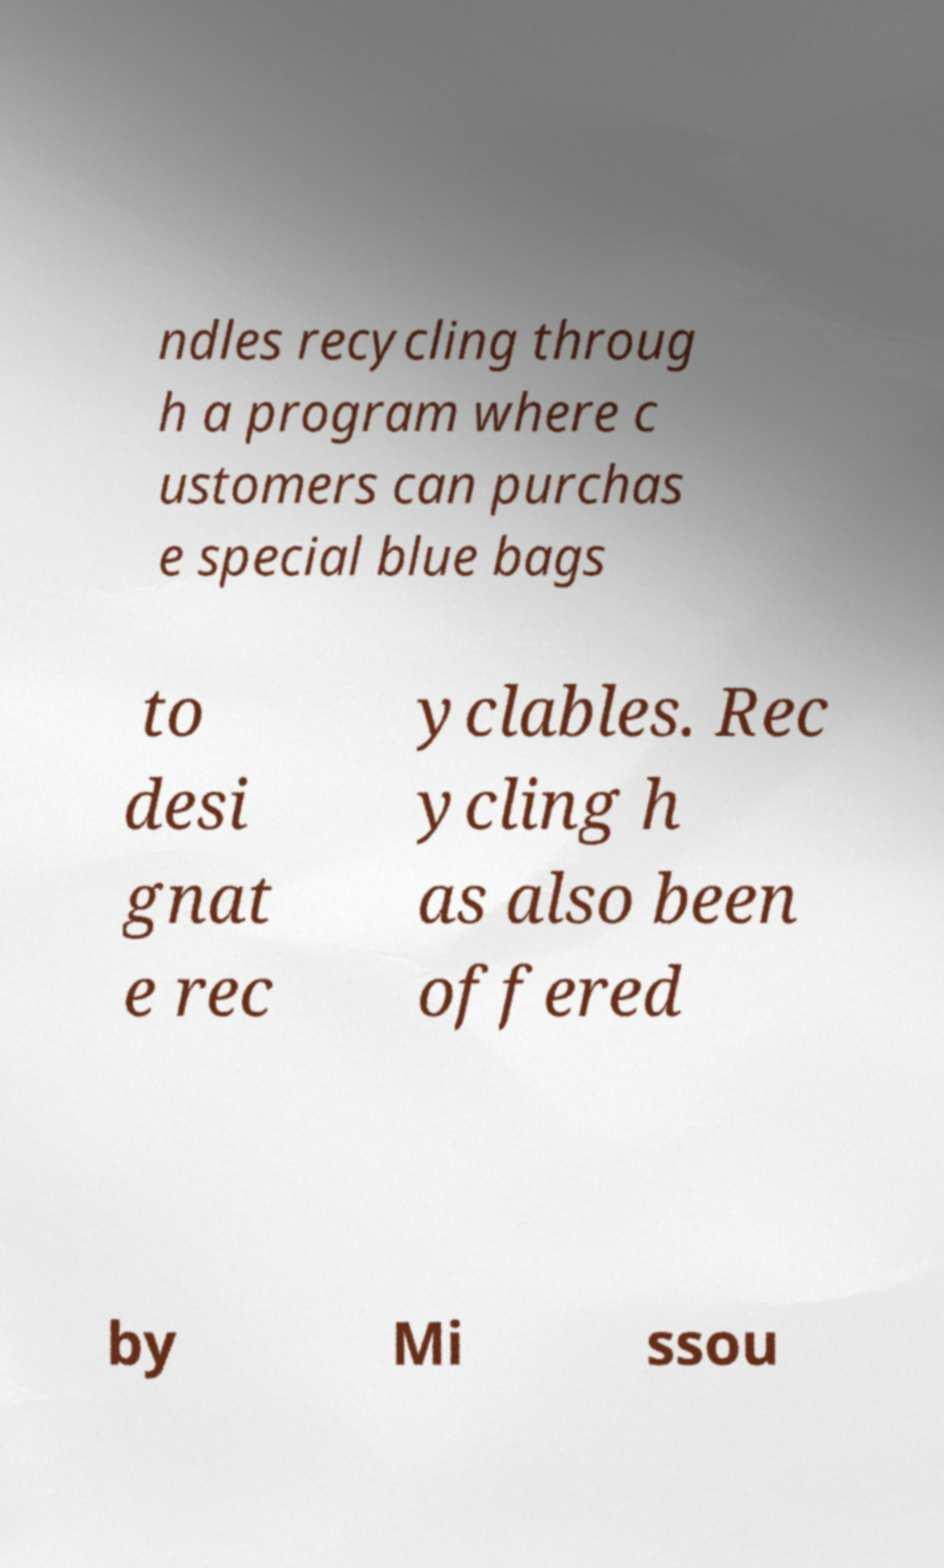Please identify and transcribe the text found in this image. ndles recycling throug h a program where c ustomers can purchas e special blue bags to desi gnat e rec yclables. Rec ycling h as also been offered by Mi ssou 